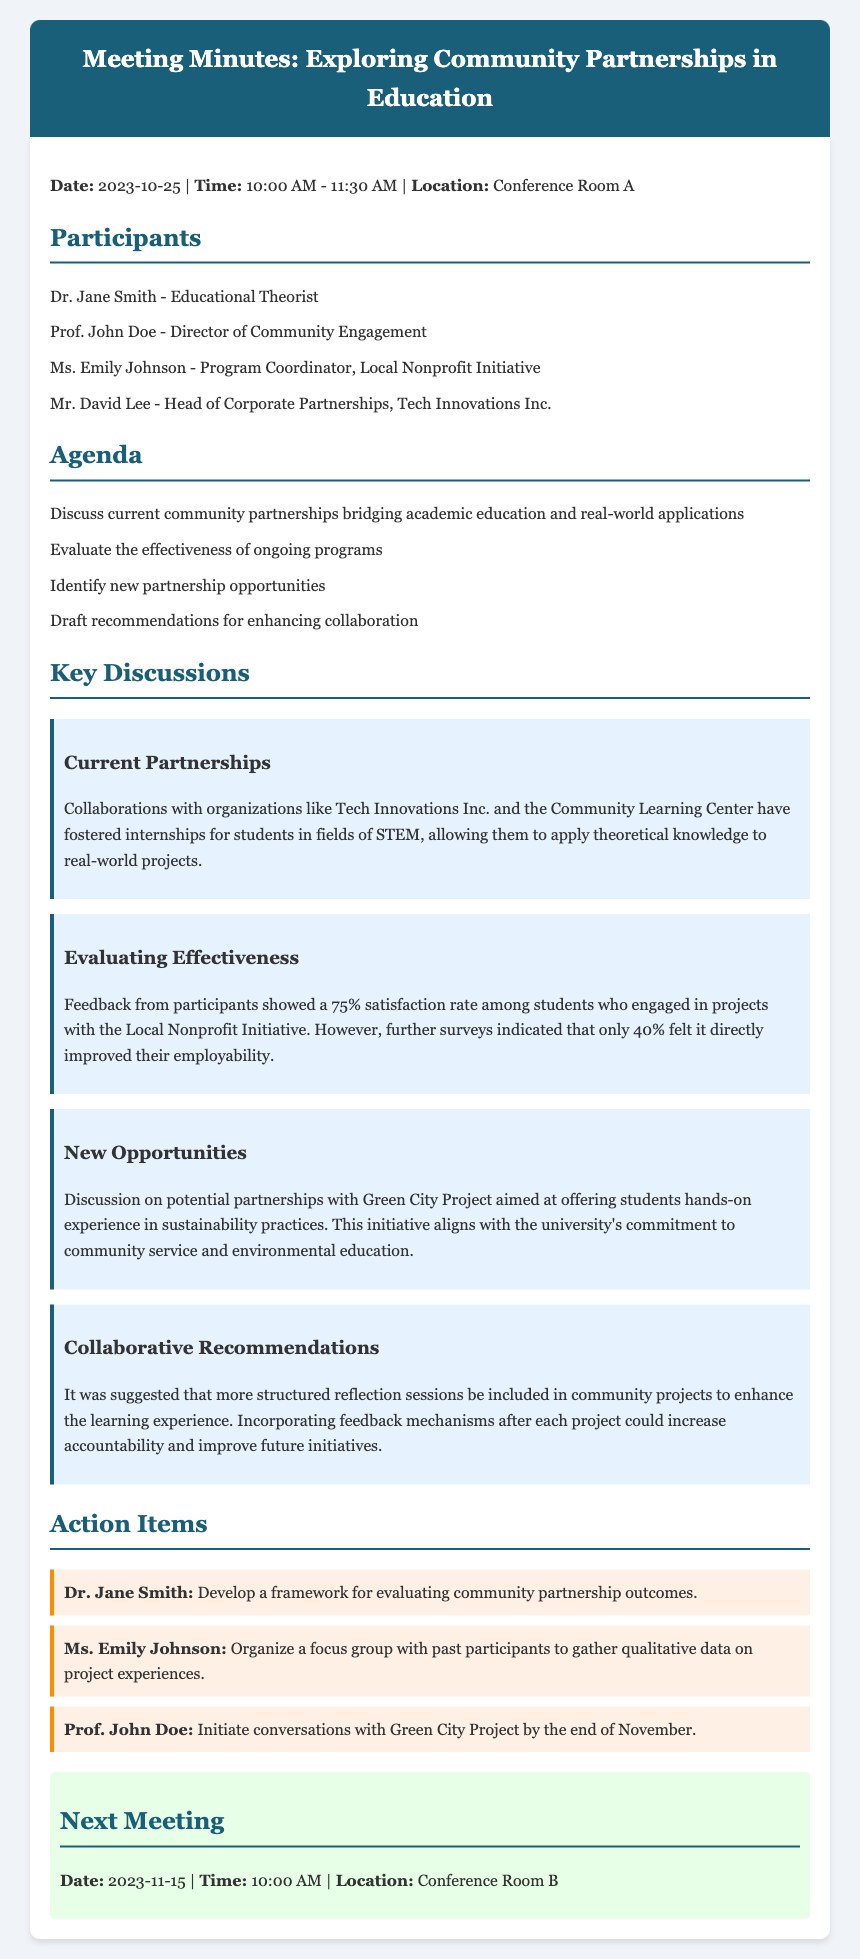What is the date of the meeting? The date of the meeting is mentioned at the beginning of the document.
Answer: 2023-10-25 Who is the Director of Community Engagement? The document lists participants, including their roles.
Answer: Prof. John Doe What was the satisfaction rate among students who engaged with the Local Nonprofit Initiative? The document states the feedback from participants regarding their satisfaction rate.
Answer: 75% What action item is assigned to Dr. Jane Smith? The action items section details responsibilities assigned to each participant.
Answer: Develop a framework for evaluating community partnership outcomes What is the proposed new partnership opportunity mentioned in the meeting? The document discusses potential new partnerships explored during the meeting.
Answer: Green City Project How many participants felt that the community project improved their employability? The effectiveness evaluation discusses the percentage of participants who felt an improvement in employability.
Answer: 40% When is the next meeting scheduled? The document provides information about the next meeting's date and time.
Answer: 2023-11-15 What type of experience does the Green City Project aim to offer students? The discussion about new opportunities specifies the nature of experiences aimed by the partnership.
Answer: Hands-on experience in sustainability practices 